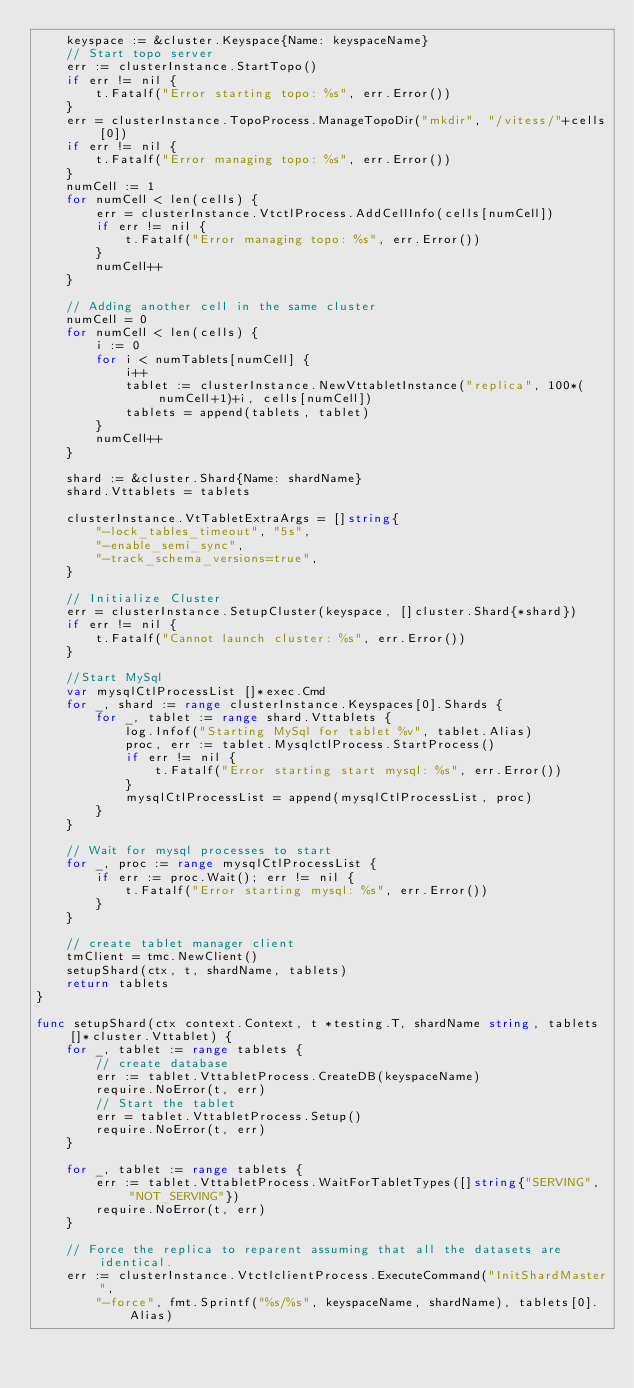Convert code to text. <code><loc_0><loc_0><loc_500><loc_500><_Go_>	keyspace := &cluster.Keyspace{Name: keyspaceName}
	// Start topo server
	err := clusterInstance.StartTopo()
	if err != nil {
		t.Fatalf("Error starting topo: %s", err.Error())
	}
	err = clusterInstance.TopoProcess.ManageTopoDir("mkdir", "/vitess/"+cells[0])
	if err != nil {
		t.Fatalf("Error managing topo: %s", err.Error())
	}
	numCell := 1
	for numCell < len(cells) {
		err = clusterInstance.VtctlProcess.AddCellInfo(cells[numCell])
		if err != nil {
			t.Fatalf("Error managing topo: %s", err.Error())
		}
		numCell++
	}

	// Adding another cell in the same cluster
	numCell = 0
	for numCell < len(cells) {
		i := 0
		for i < numTablets[numCell] {
			i++
			tablet := clusterInstance.NewVttabletInstance("replica", 100*(numCell+1)+i, cells[numCell])
			tablets = append(tablets, tablet)
		}
		numCell++
	}

	shard := &cluster.Shard{Name: shardName}
	shard.Vttablets = tablets

	clusterInstance.VtTabletExtraArgs = []string{
		"-lock_tables_timeout", "5s",
		"-enable_semi_sync",
		"-track_schema_versions=true",
	}

	// Initialize Cluster
	err = clusterInstance.SetupCluster(keyspace, []cluster.Shard{*shard})
	if err != nil {
		t.Fatalf("Cannot launch cluster: %s", err.Error())
	}

	//Start MySql
	var mysqlCtlProcessList []*exec.Cmd
	for _, shard := range clusterInstance.Keyspaces[0].Shards {
		for _, tablet := range shard.Vttablets {
			log.Infof("Starting MySql for tablet %v", tablet.Alias)
			proc, err := tablet.MysqlctlProcess.StartProcess()
			if err != nil {
				t.Fatalf("Error starting start mysql: %s", err.Error())
			}
			mysqlCtlProcessList = append(mysqlCtlProcessList, proc)
		}
	}

	// Wait for mysql processes to start
	for _, proc := range mysqlCtlProcessList {
		if err := proc.Wait(); err != nil {
			t.Fatalf("Error starting mysql: %s", err.Error())
		}
	}

	// create tablet manager client
	tmClient = tmc.NewClient()
	setupShard(ctx, t, shardName, tablets)
	return tablets
}

func setupShard(ctx context.Context, t *testing.T, shardName string, tablets []*cluster.Vttablet) {
	for _, tablet := range tablets {
		// create database
		err := tablet.VttabletProcess.CreateDB(keyspaceName)
		require.NoError(t, err)
		// Start the tablet
		err = tablet.VttabletProcess.Setup()
		require.NoError(t, err)
	}

	for _, tablet := range tablets {
		err := tablet.VttabletProcess.WaitForTabletTypes([]string{"SERVING", "NOT_SERVING"})
		require.NoError(t, err)
	}

	// Force the replica to reparent assuming that all the datasets are identical.
	err := clusterInstance.VtctlclientProcess.ExecuteCommand("InitShardMaster",
		"-force", fmt.Sprintf("%s/%s", keyspaceName, shardName), tablets[0].Alias)</code> 